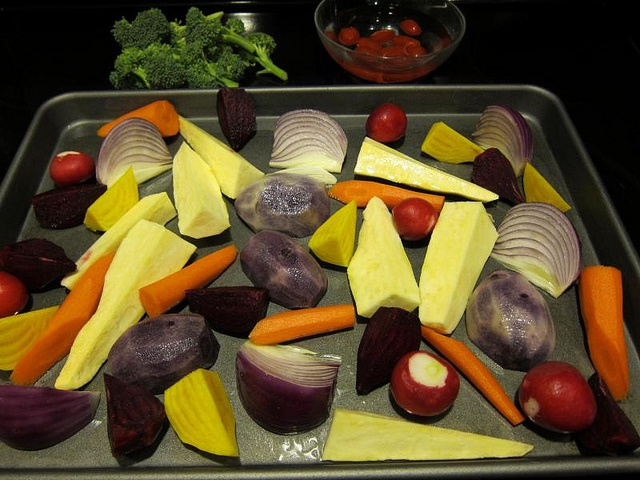Describe the objects in this image and their specific colors. I can see broccoli in black, darkgreen, and olive tones, bowl in black, maroon, and gray tones, carrot in black, maroon, red, and brown tones, carrot in black, red, brown, and maroon tones, and carrot in black, red, and orange tones in this image. 